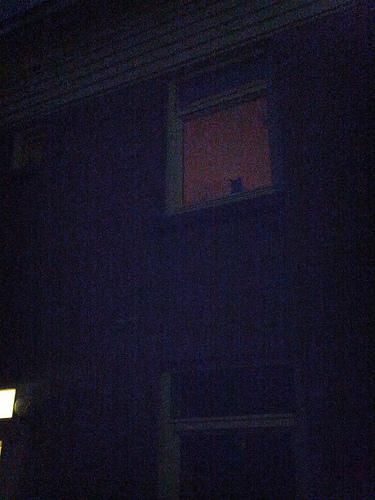Question: who is else is on the window?
Choices:
A. A man.
B. A woman.
C. A dog.
D. No one.
Answer with the letter. Answer: D Question: where was the pic taken from?
Choices:
A. Inside a car.
B. Outside the house.
C. Inside the house.
D. The top of a mountain.
Answer with the letter. Answer: B Question: when was the pic teken?
Choices:
A. During the day.
B. At dawn.
C. At dusk.
D. At night.
Answer with the letter. Answer: D Question: how many cats are there?
Choices:
A. 2.
B. 3.
C. 4.
D. 1.
Answer with the letter. Answer: D Question: what is the condition of the pic?
Choices:
A. Sharp.
B. Torn.
C. Pristine.
D. Blurred.
Answer with the letter. Answer: D 